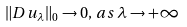<formula> <loc_0><loc_0><loc_500><loc_500>\| D u _ { \lambda } \| _ { 0 } \rightarrow 0 , \, a s \, \lambda \rightarrow + \infty</formula> 